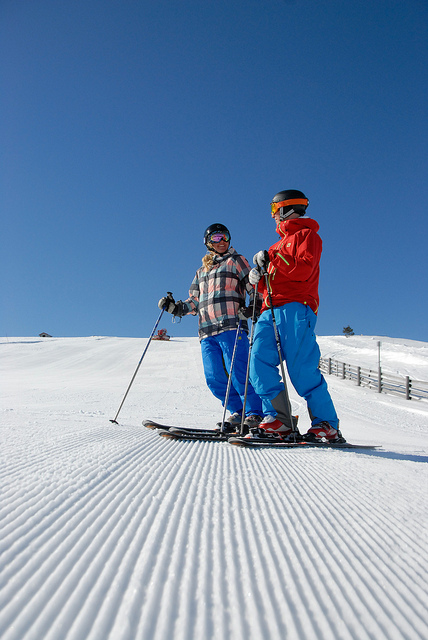How many chairs are in the picture? The image doesn't contain any chairs; instead, it features two individuals equipped for skiing on a snowy slope with clear blue skies above. 